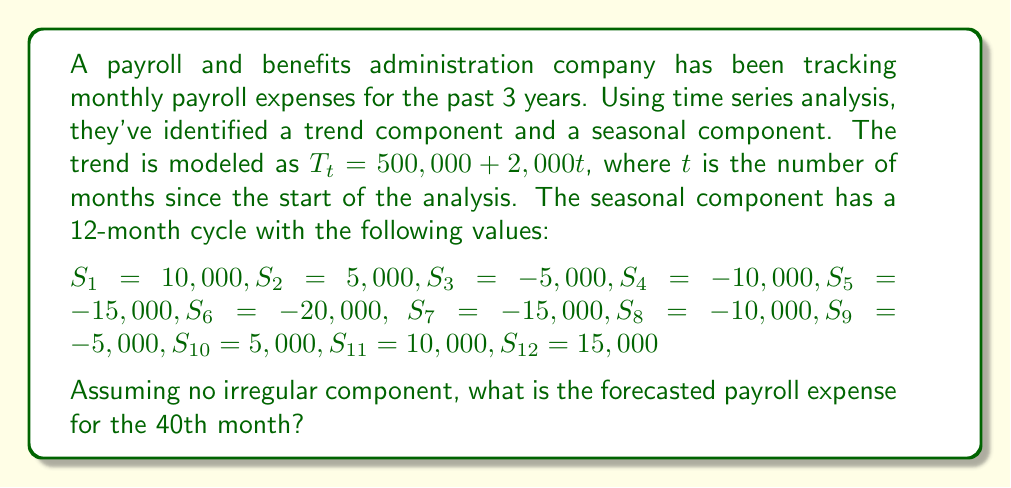Help me with this question. To forecast the payroll expense for the 40th month, we need to combine the trend and seasonal components:

1. Calculate the trend component for t = 40:
   $$T_{40} = 500,000 + 2,000(40) = 500,000 + 80,000 = 580,000$$

2. Determine the seasonal component for the 40th month:
   - 40 ÷ 12 = 3 remainder 4
   - This means the 40th month corresponds to the 4th month in the seasonal cycle
   - $S_4 = -10,000$

3. Combine the trend and seasonal components:
   $$\text{Forecast} = T_{40} + S_4 = 580,000 + (-10,000) = 570,000$$

Therefore, the forecasted payroll expense for the 40th month is $570,000.
Answer: $570,000 